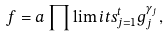<formula> <loc_0><loc_0><loc_500><loc_500>f = a \prod \lim i t s _ { j = 1 } ^ { t } g _ { j } ^ { \gamma _ { j } } ,</formula> 